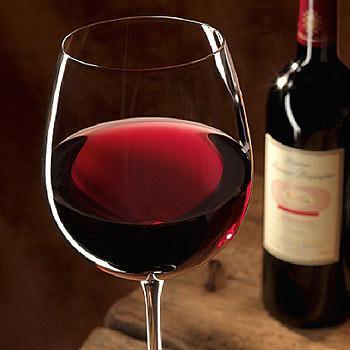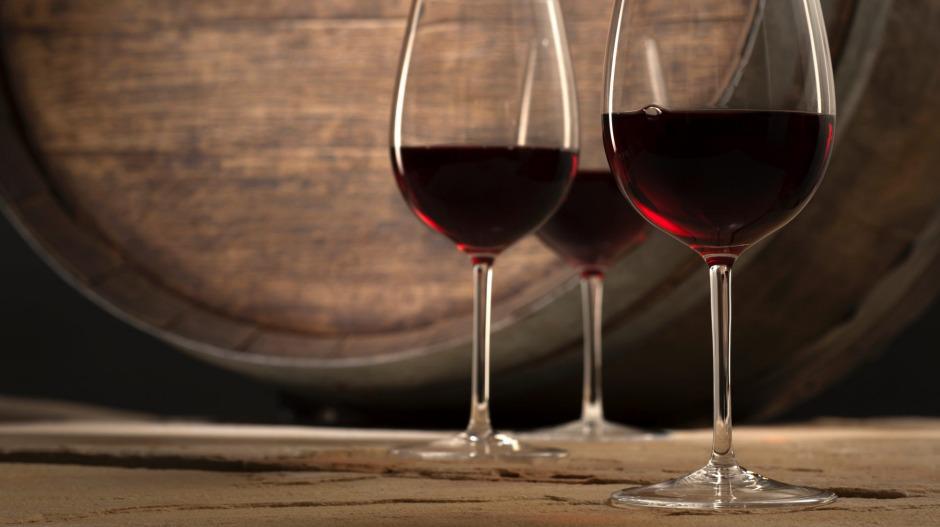The first image is the image on the left, the second image is the image on the right. Assess this claim about the two images: "There are four wine glasses, and some of them are in front of the others.". Correct or not? Answer yes or no. Yes. The first image is the image on the left, the second image is the image on the right. Evaluate the accuracy of this statement regarding the images: "There are more than two glasses with wine in them". Is it true? Answer yes or no. Yes. 